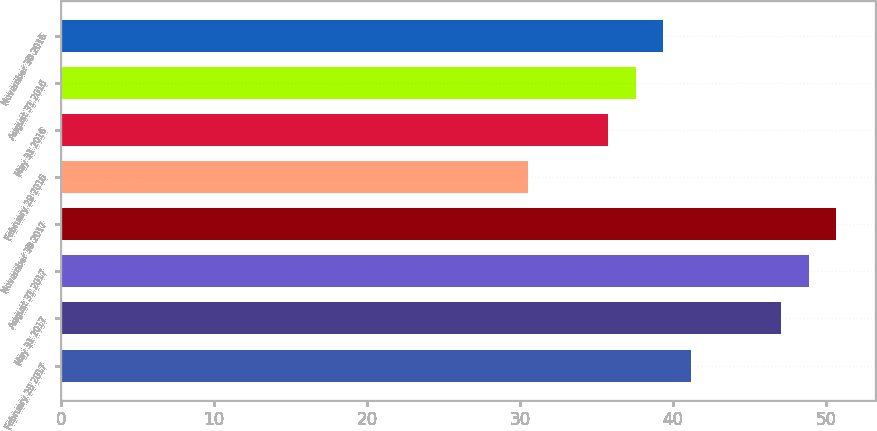Convert chart. <chart><loc_0><loc_0><loc_500><loc_500><bar_chart><fcel>February 28 2017<fcel>May 31 2017<fcel>August 31 2017<fcel>November 30 2017<fcel>February 29 2016<fcel>May 31 2016<fcel>August 31 2016<fcel>November 30 2016<nl><fcel>41.17<fcel>47.06<fcel>48.86<fcel>50.66<fcel>30.5<fcel>35.77<fcel>37.57<fcel>39.37<nl></chart> 